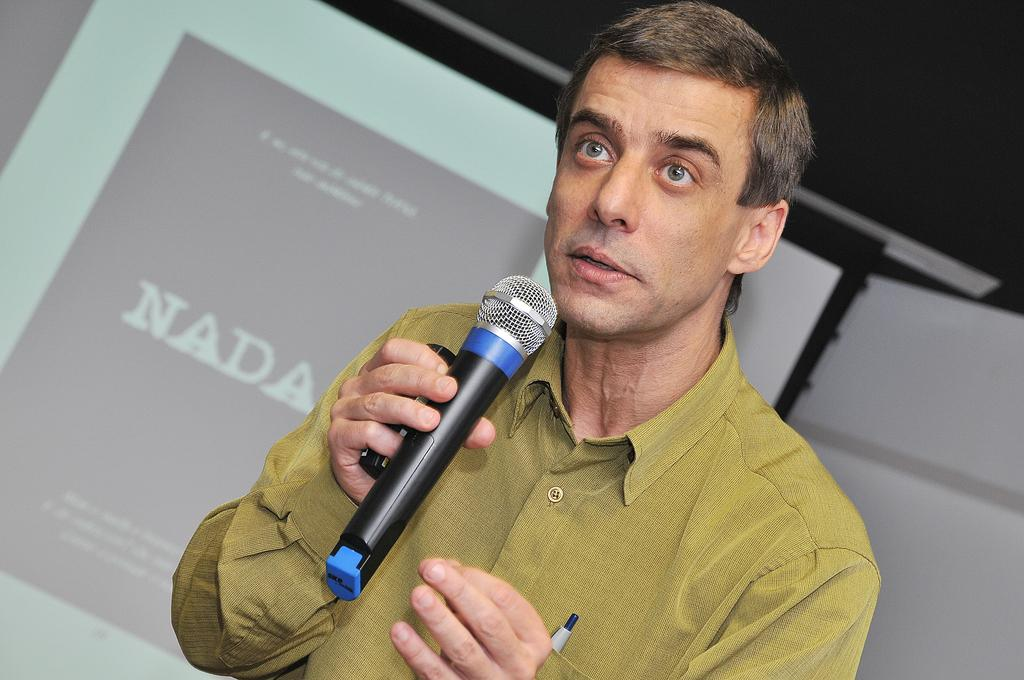What is the person holding in the image? The person is holding a microphone. What is the person doing with the microphone? The person is talking. What color is the shirt the person is wearing? The person is wearing a yellow shirt. What can be seen behind the person? There is a screen visible behind the person. What type of crayon is the person using to draw on the hill in the image? There is no crayon or hill present in the image. 